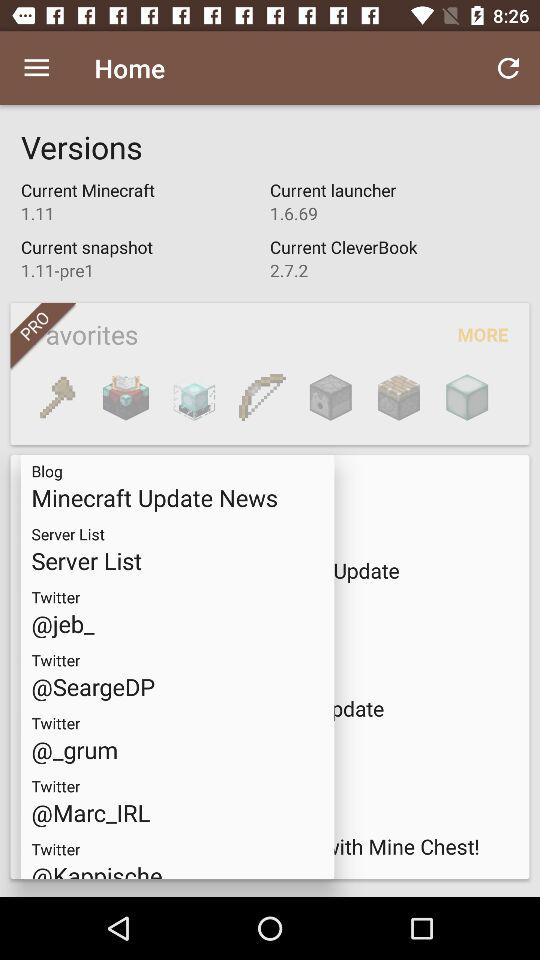What version is used in the current Minecraft option? The version is 1.11. 